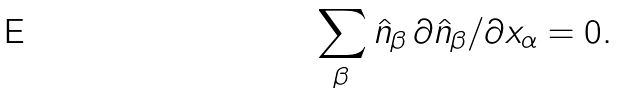Convert formula to latex. <formula><loc_0><loc_0><loc_500><loc_500>\sum _ { \beta } \hat { n } _ { \beta } \, \partial \hat { n } _ { \beta } / \partial x _ { \alpha } = 0 .</formula> 